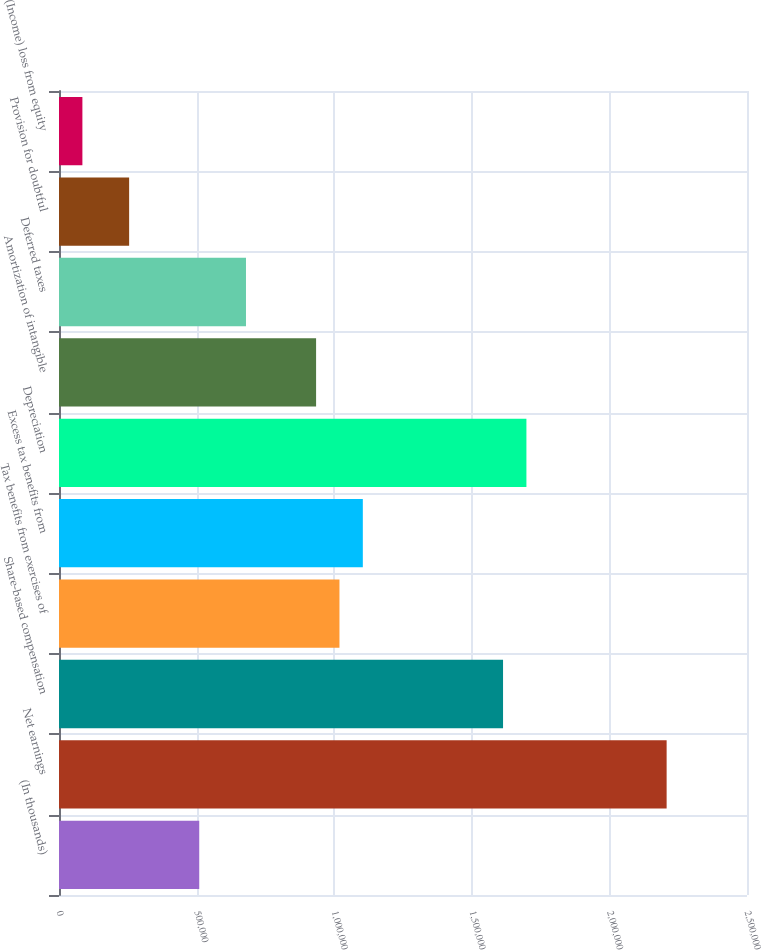<chart> <loc_0><loc_0><loc_500><loc_500><bar_chart><fcel>(In thousands)<fcel>Net earnings<fcel>Share-based compensation<fcel>Tax benefits from exercises of<fcel>Excess tax benefits from<fcel>Depreciation<fcel>Amortization of intangible<fcel>Deferred taxes<fcel>Provision for doubtful<fcel>(Income) loss from equity<nl><fcel>509602<fcel>2.20797e+06<fcel>1.61354e+06<fcel>1.01911e+06<fcel>1.10403e+06<fcel>1.69846e+06<fcel>934193<fcel>679438<fcel>254847<fcel>85010.3<nl></chart> 